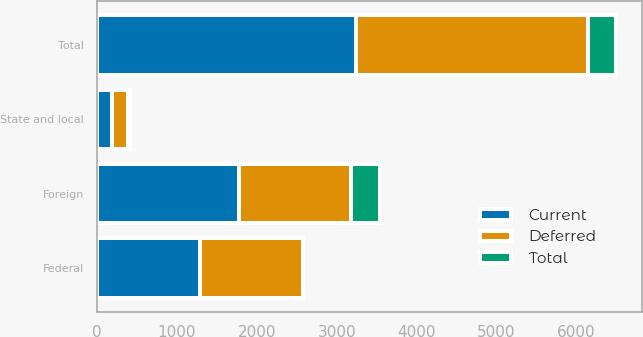Convert chart to OTSL. <chart><loc_0><loc_0><loc_500><loc_500><stacked_bar_chart><ecel><fcel>Federal<fcel>State and local<fcel>Foreign<fcel>Total<nl><fcel>Current<fcel>1290<fcel>184<fcel>1774<fcel>3248<nl><fcel>Total<fcel>2<fcel>22<fcel>367<fcel>347<nl><fcel>Deferred<fcel>1288<fcel>206<fcel>1407<fcel>2901<nl></chart> 